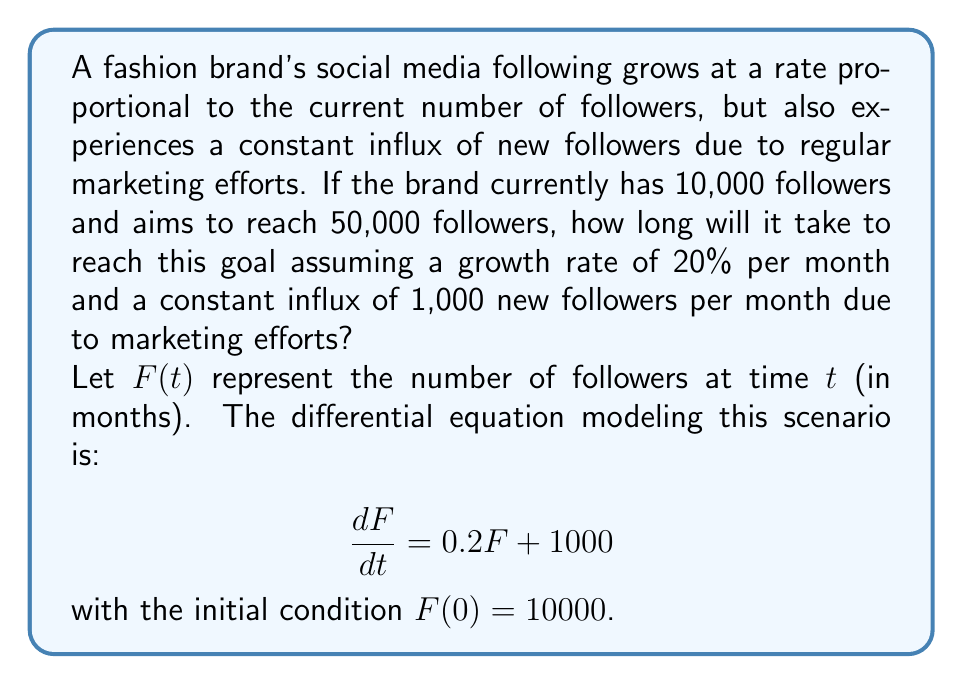Solve this math problem. To solve this problem, we need to solve the given differential equation and then find the time when $F(t) = 50000$.

1. First, let's solve the differential equation:
   $$\frac{dF}{dt} = 0.2F + 1000$$

   This is a linear first-order differential equation. We can solve it using the integrating factor method.

2. The integrating factor is $e^{\int 0.2 dt} = e^{0.2t}$. Multiply both sides by this:
   $$e^{0.2t}\frac{dF}{dt} = 0.2Fe^{0.2t} + 1000e^{0.2t}$$

3. The left side is now the derivative of $Fe^{0.2t}$:
   $$\frac{d}{dt}(Fe^{0.2t}) = 1000e^{0.2t}$$

4. Integrate both sides:
   $$Fe^{0.2t} = 5000e^{0.2t} + C$$

5. Solve for $F$:
   $$F = 5000 + Ce^{-0.2t}$$

6. Use the initial condition $F(0) = 10000$ to find $C$:
   $$10000 = 5000 + C$$
   $$C = 5000$$

7. The general solution is:
   $$F(t) = 5000 + 5000e^{-0.2t}$$

8. Now, we need to find $t$ when $F(t) = 50000$:
   $$50000 = 5000 + 5000e^{-0.2t}$$

9. Solve for $t$:
   $$45000 = 5000e^{-0.2t}$$
   $$9 = e^{-0.2t}$$
   $$\ln(9) = -0.2t$$
   $$t = -\frac{\ln(9)}{0.2} \approx 11.15$$

Therefore, it will take approximately 11.15 months to reach 50,000 followers.
Answer: It will take approximately 11.15 months for the fashion brand to reach 50,000 followers. 